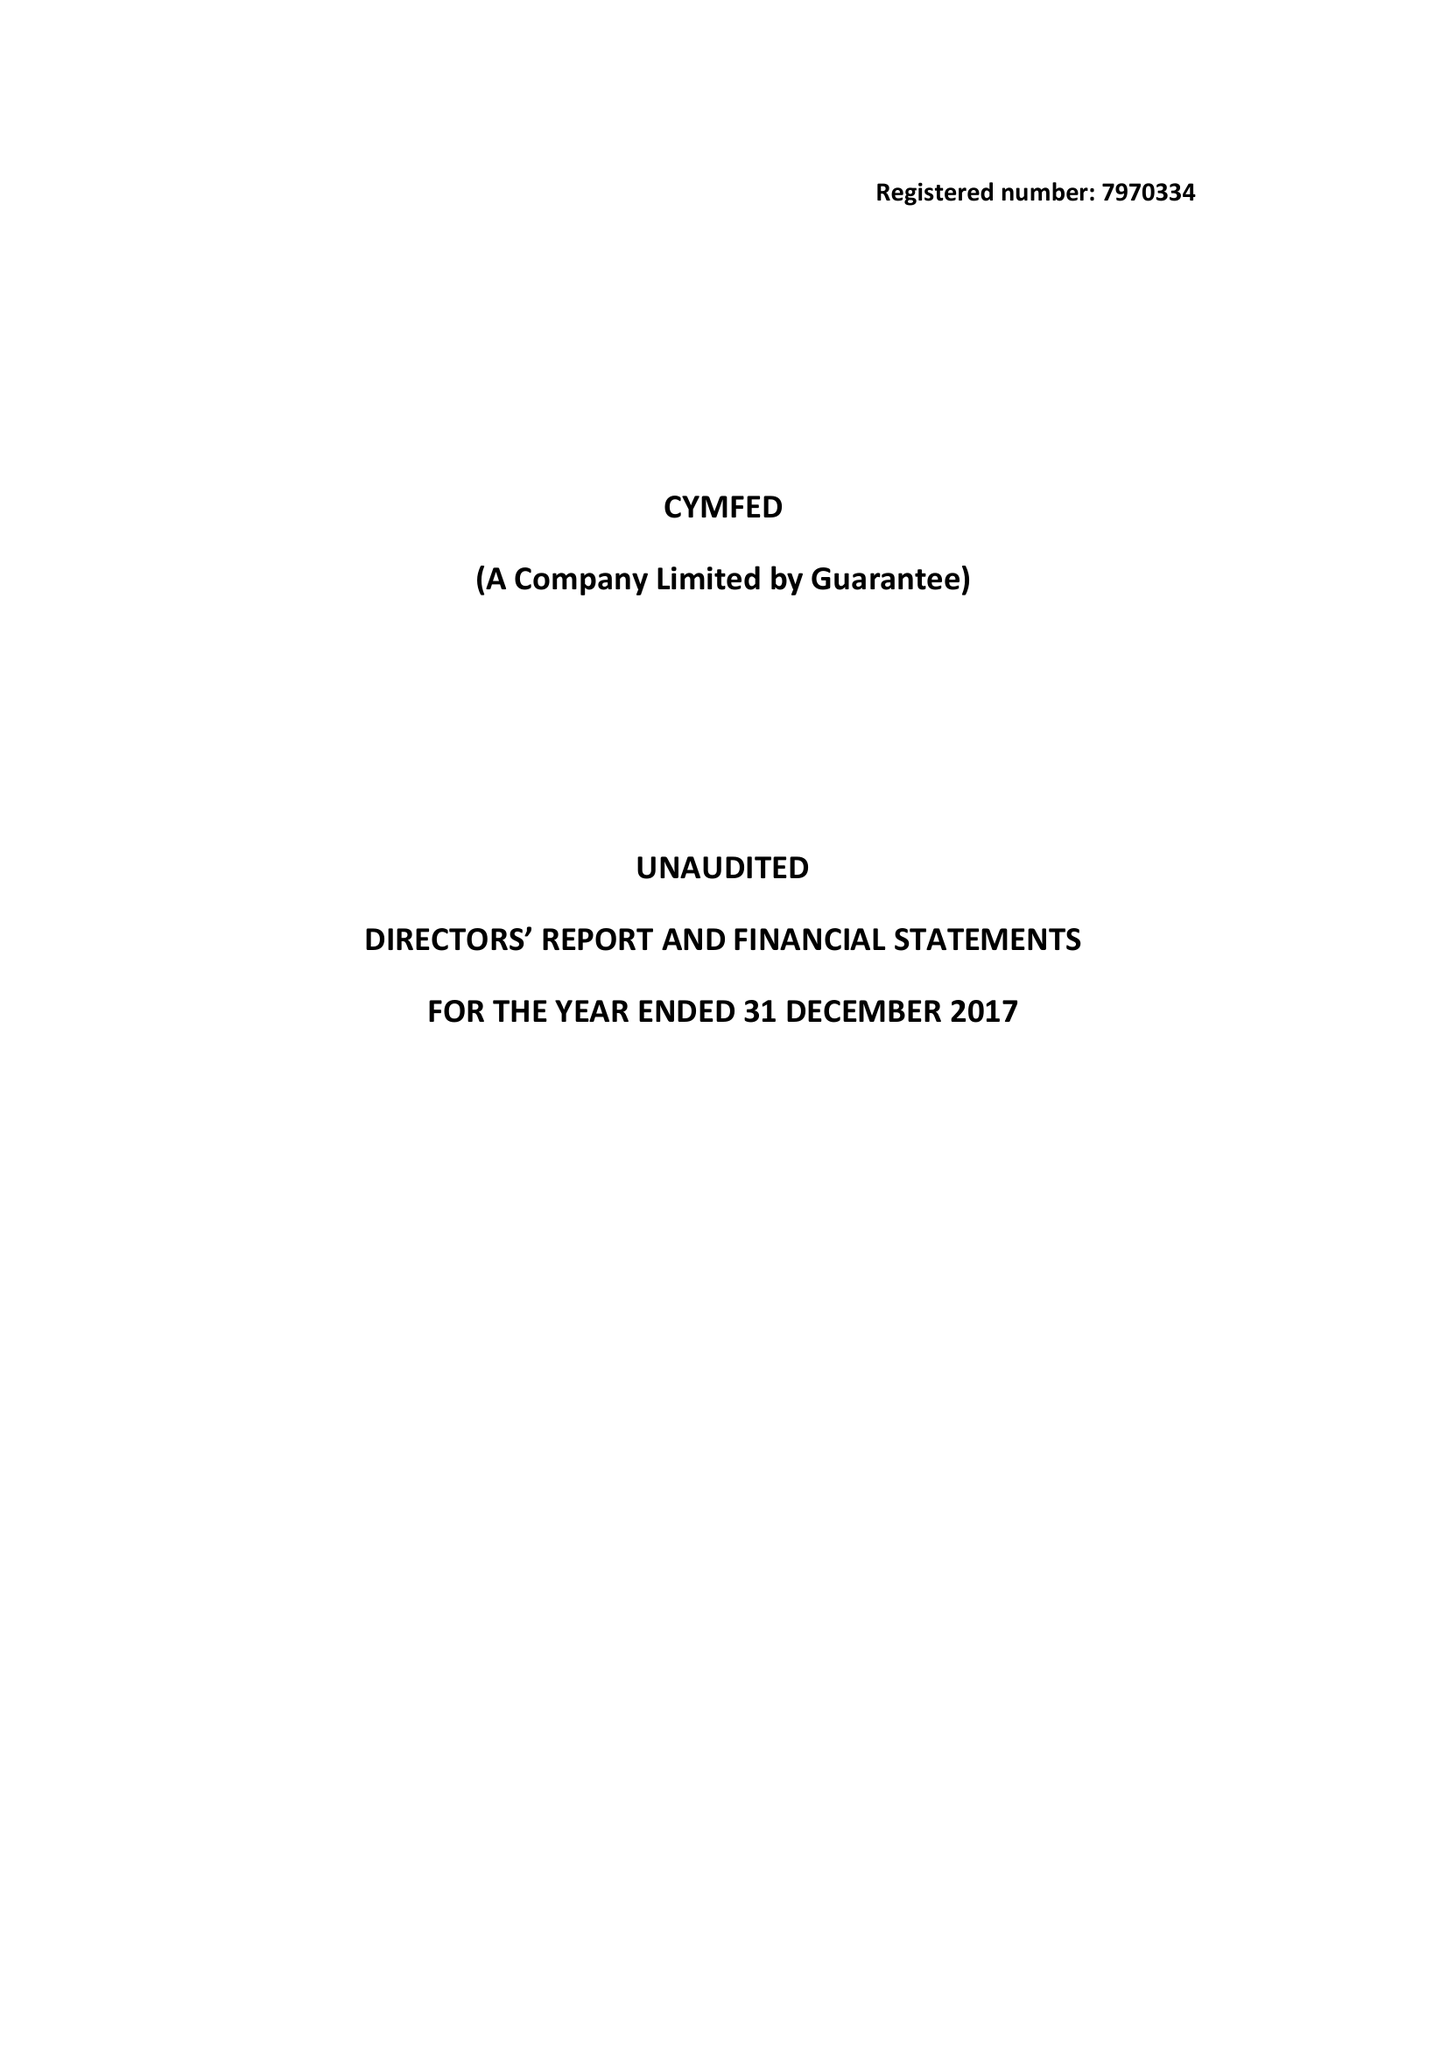What is the value for the charity_number?
Answer the question using a single word or phrase. 1158109 